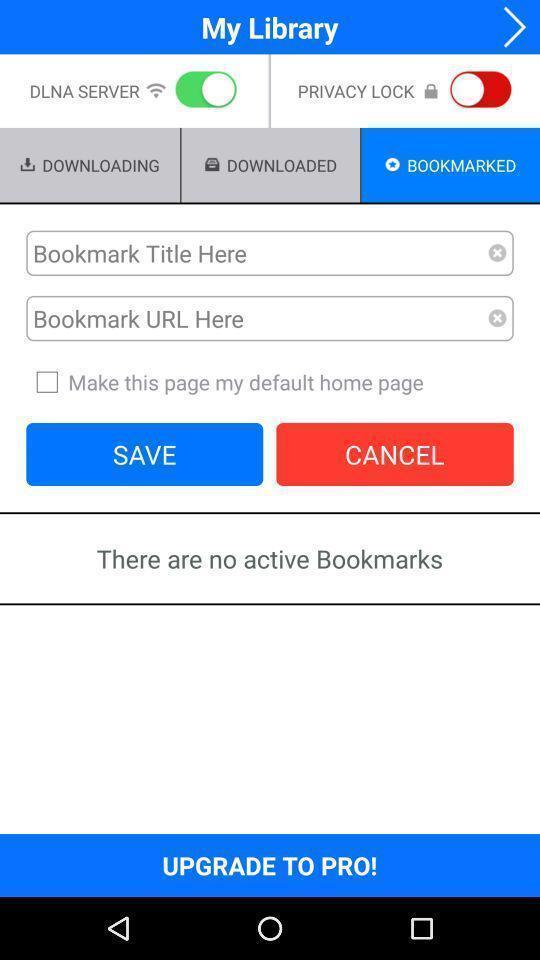Give me a narrative description of this picture. Page showing the multiple options my library app. 